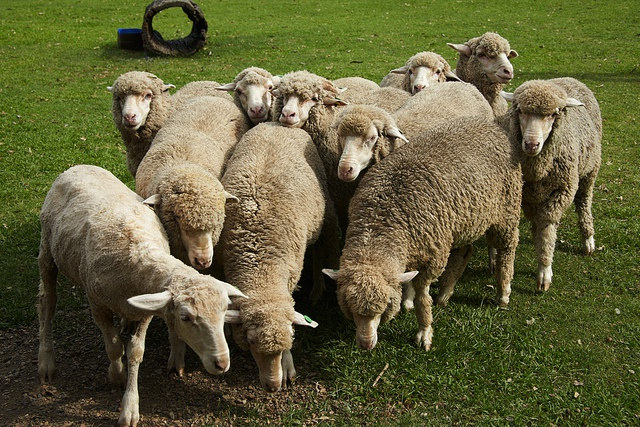Describe the objects in this image and their specific colors. I can see sheep in olive, black, beige, darkgreen, and gray tones, sheep in olive, tan, black, and gray tones, sheep in olive, tan, black, and gray tones, sheep in olive, black, tan, and darkgreen tones, and sheep in olive and tan tones in this image. 